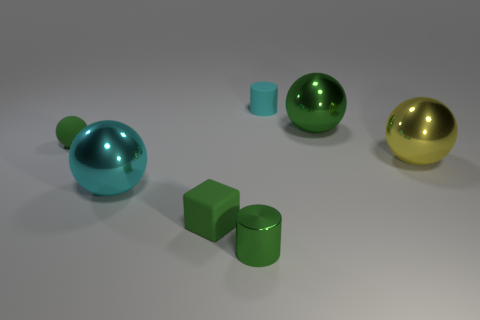Subtract all big cyan spheres. How many spheres are left? 3 Subtract all brown cylinders. How many green spheres are left? 2 Subtract all cyan spheres. How many spheres are left? 3 Add 2 large yellow metal balls. How many objects exist? 9 Subtract all cubes. How many objects are left? 6 Subtract 0 blue spheres. How many objects are left? 7 Subtract all purple spheres. Subtract all yellow cylinders. How many spheres are left? 4 Subtract all small cyan rubber objects. Subtract all metallic spheres. How many objects are left? 3 Add 6 tiny rubber cubes. How many tiny rubber cubes are left? 7 Add 2 tiny purple blocks. How many tiny purple blocks exist? 2 